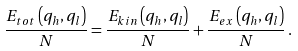<formula> <loc_0><loc_0><loc_500><loc_500>\frac { E _ { t o t } \left ( q _ { h } , q _ { l } \right ) } { N } = \frac { E _ { k i n } \left ( q _ { h } , q _ { l } \right ) } { N } + \frac { E _ { e x } \left ( q _ { h } , q _ { l } \right ) } { N } \, .</formula> 